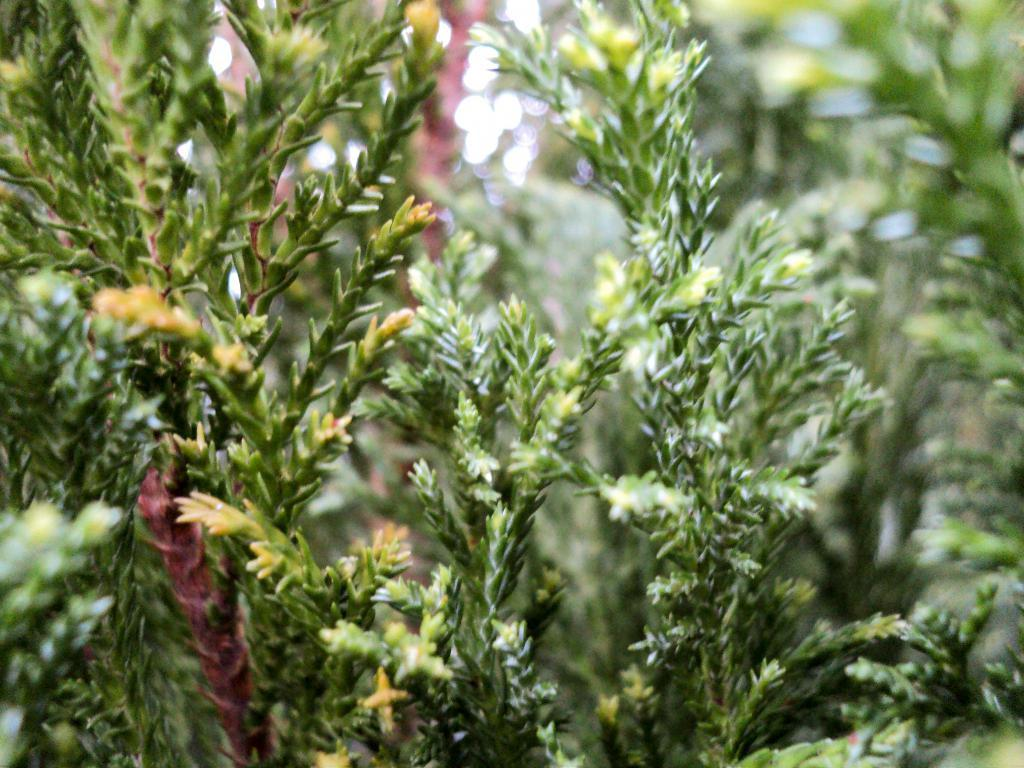What part of a plant can be seen in the image? The stems of a plant can be seen in the image. What type of butter is being used to grease the tray in the image? There is no tray or butter present in the image; it only contains the stems of a plant. 